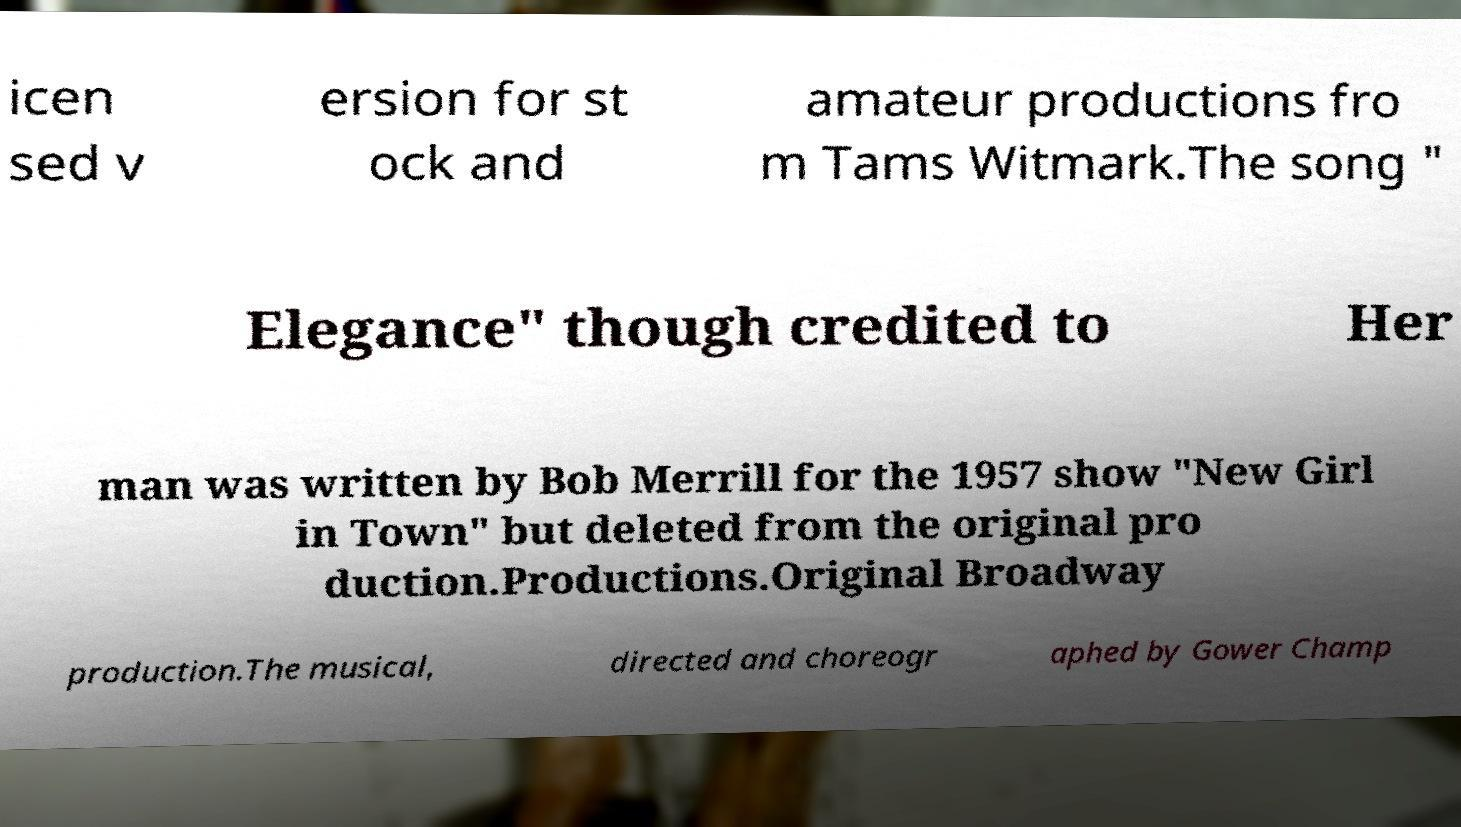Could you extract and type out the text from this image? icen sed v ersion for st ock and amateur productions fro m Tams Witmark.The song " Elegance" though credited to Her man was written by Bob Merrill for the 1957 show "New Girl in Town" but deleted from the original pro duction.Productions.Original Broadway production.The musical, directed and choreogr aphed by Gower Champ 